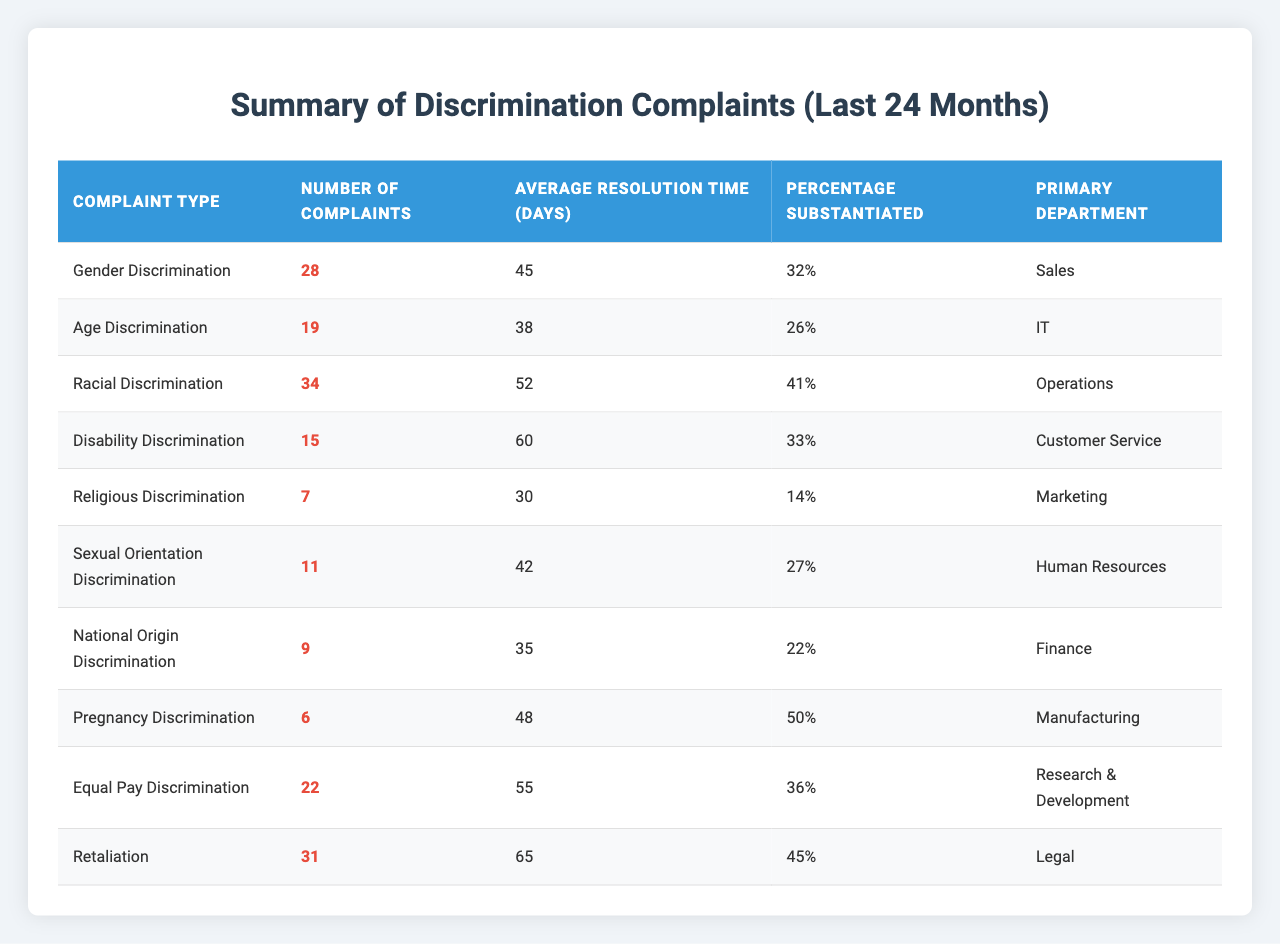What is the most common complaint type filed in the last 24 months? The complaint type with the highest number of complaints is Racial Discrimination, with 34 complaints filed.
Answer: Racial Discrimination What is the average resolution time for Disability Discrimination complaints? The average resolution time for Disability Discrimination complaints is 60 days.
Answer: 60 days Which department has the highest percentage of substantiated complaints? Racial Discrimination has the highest percentage of substantiated complaints at 41%.
Answer: 41% How many Total Complaints were filed for Gender and Age Discrimination combined? Adding the number of complaints for Gender Discrimination (28) and Age Discrimination (19) gives a total of 47 complaints.
Answer: 47 Is the average resolution time for Sexual Orientation Discrimination higher than for Religious Discrimination? The average resolution time for Sexual Orientation Discrimination is 42 days, while it is 30 days for Religious Discrimination, thus confirming it is higher.
Answer: Yes What is the total number of complaints for National Origin, Pregnancy, and Equal Pay Discriminations combined? For National Origin (9), Pregnancy (6), and Equal Pay (22), the sum is 9 + 6 + 22 = 37.
Answer: 37 Which complaint type takes the longest average resolution time? Reviewing the average resolution times, Disability Discrimination with 60 days has the longest resolution time.
Answer: Disability Discrimination What percentage of complaints for Retaliation were substantiated? The table indicates that 45% of Retaliation complaints were substantiated.
Answer: 45% How does the average resolution time of Age Discrimination compare to Equal Pay Discrimination? Age Discrimination has an average resolution time of 38 days, while Equal Pay Discrimination has 55 days, making Equal Pay slower to resolve.
Answer: Equal Pay is slower Which complaint type in the IT department has fewer complaints than in the Customer Service department? Age Discrimination (19 complaints) has fewer than Disability Discrimination (15 complaints in Customer Service).
Answer: Age Discrimination 